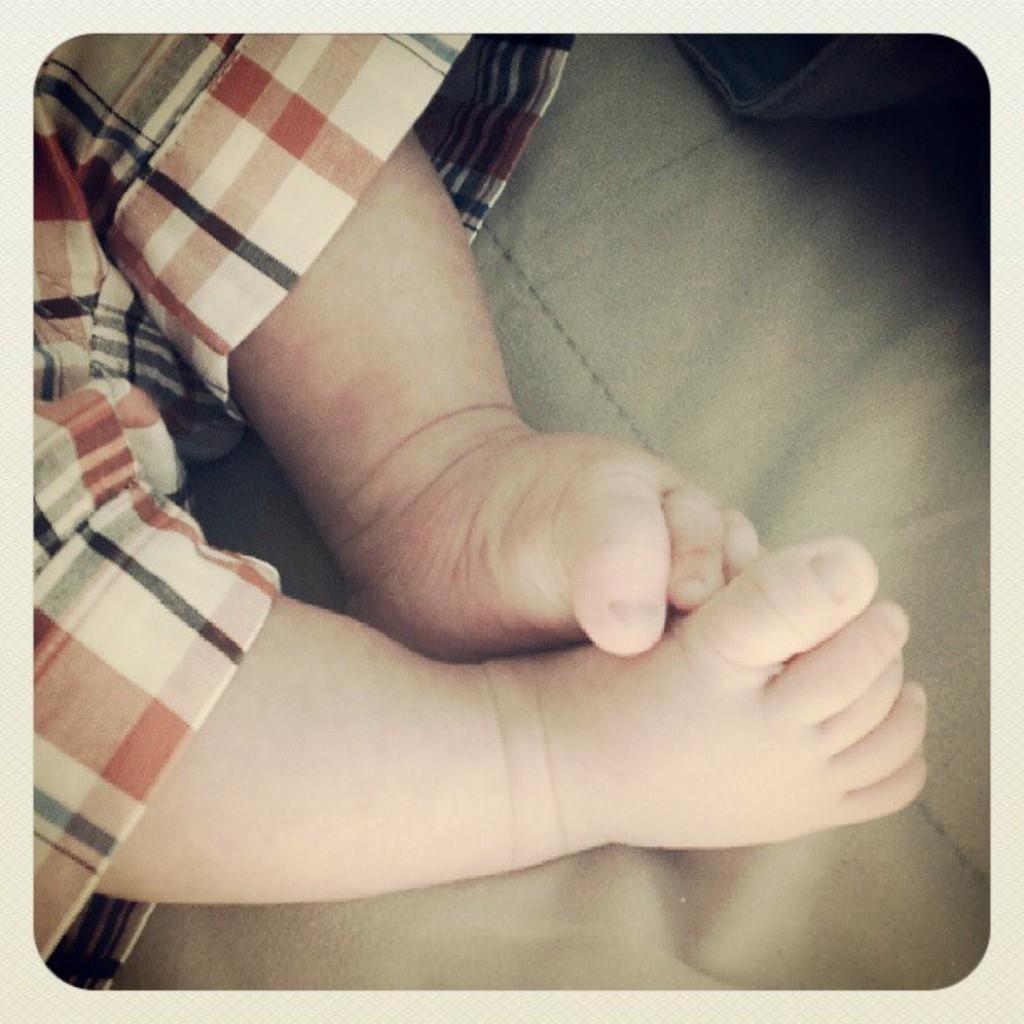In one or two sentences, can you explain what this image depicts? In this image there is a person and there is an object which is black in colour, which is on the surface which is brown in colour. 